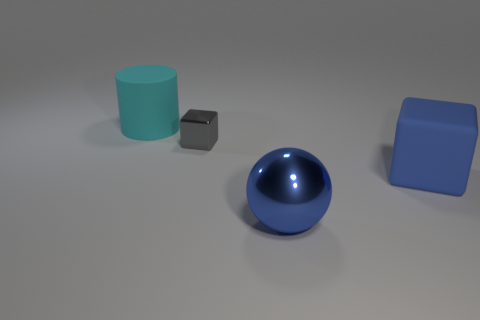Subtract all big gray shiny things. Subtract all large matte things. How many objects are left? 2 Add 2 large matte cylinders. How many large matte cylinders are left? 3 Add 1 gray cubes. How many gray cubes exist? 2 Add 4 big things. How many objects exist? 8 Subtract 0 blue cylinders. How many objects are left? 4 Subtract all spheres. How many objects are left? 3 Subtract 1 cylinders. How many cylinders are left? 0 Subtract all gray blocks. Subtract all green cylinders. How many blocks are left? 1 Subtract all gray balls. How many gray blocks are left? 1 